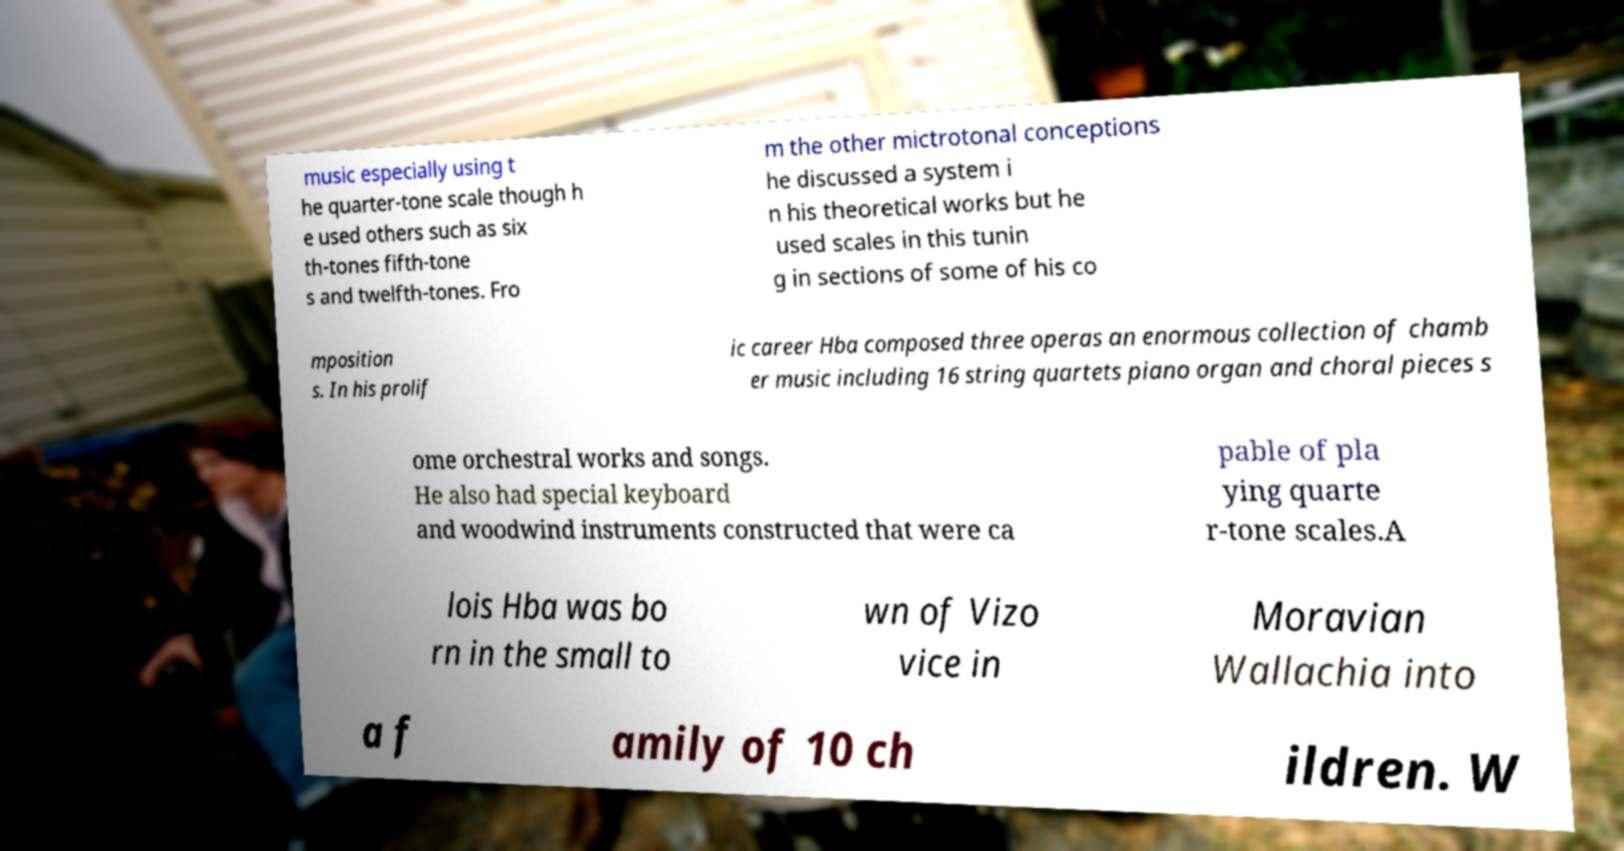I need the written content from this picture converted into text. Can you do that? music especially using t he quarter-tone scale though h e used others such as six th-tones fifth-tone s and twelfth-tones. Fro m the other mictrotonal conceptions he discussed a system i n his theoretical works but he used scales in this tunin g in sections of some of his co mposition s. In his prolif ic career Hba composed three operas an enormous collection of chamb er music including 16 string quartets piano organ and choral pieces s ome orchestral works and songs. He also had special keyboard and woodwind instruments constructed that were ca pable of pla ying quarte r-tone scales.A lois Hba was bo rn in the small to wn of Vizo vice in Moravian Wallachia into a f amily of 10 ch ildren. W 